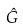Convert formula to latex. <formula><loc_0><loc_0><loc_500><loc_500>\hat { G }</formula> 